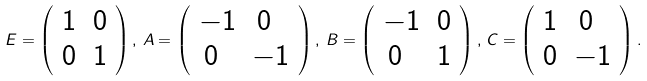<formula> <loc_0><loc_0><loc_500><loc_500>E = \left ( \begin{array} { l l } 1 & 0 \\ 0 & 1 \end{array} \right ) , \, A = \left ( \begin{array} { l l } - 1 & \, 0 \\ \, 0 & - 1 \end{array} \right ) , \, B = \left ( \begin{array} { l l } - 1 & 0 \\ \, 0 & 1 \end{array} \right ) , \, C = \left ( \begin{array} { l l } 1 & \, 0 \\ 0 & - 1 \end{array} \right ) .</formula> 